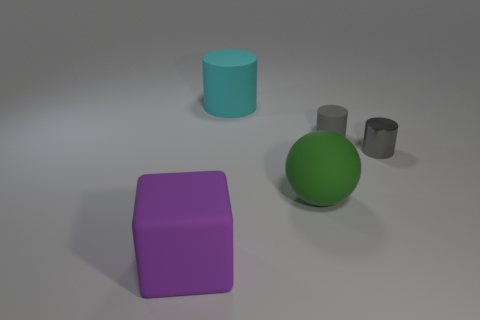Add 1 cyan cylinders. How many objects exist? 6 Subtract all blocks. How many objects are left? 4 Add 4 matte spheres. How many matte spheres are left? 5 Add 4 small red metal objects. How many small red metal objects exist? 4 Subtract 0 purple cylinders. How many objects are left? 5 Subtract all small purple spheres. Subtract all big matte objects. How many objects are left? 2 